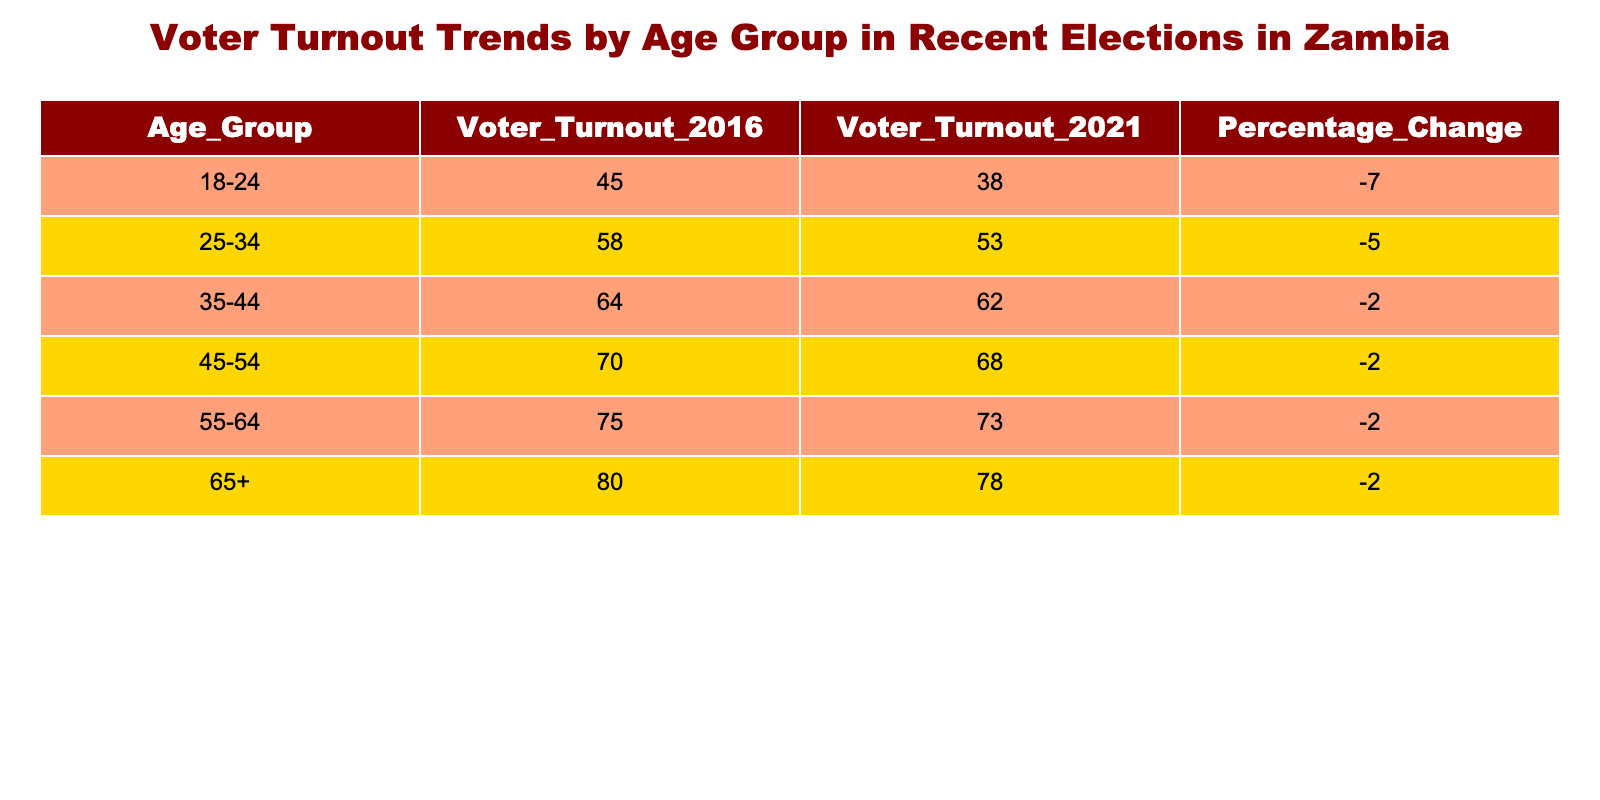What was the voter turnout for the age group 25-34 in the 2021 elections? The table shows that the voter turnout for the age group 25-34 in the 2021 elections is 53.
Answer: 53 What is the percentage change in voter turnout for those aged 18-24 from the 2016 to 2021 elections? The table indicates a percentage change of -7 from 45 to 38.
Answer: -7 Which age group had the highest voter turnout in 2016? According to the table, the age group 65+ had the highest voter turnout at 80 in 2016.
Answer: 65+ What is the average voter turnout across all age groups in the 2021 elections? To find the average, we sum the voter turnout values for 2021 (38 + 53 + 62 + 68 + 73 + 78 = 372) and divide by the number of age groups (6), resulting in an average of 62.
Answer: 62 Is it true that the voter turnout for the age group 35-44 decreased from 2016 to 2021? Yes, the table shows a decrease from 64 in 2016 to 62 in 2021 for the age group 35-44.
Answer: Yes What age group experienced the least decline in voter turnout from 2016 to 2021? The least decline is seen in the age group 35-44, with a decrease of -2, as all other age groups experienced a decline of -2 or worse.
Answer: 35-44 What can you conclude about the trends in voter turnout for the youngest age group compared to the oldest? The table indicates that the voter turnout for the youngest age group (18-24) decreased by 7, while the oldest age group (65+) only decreased by 2, showcasing that younger voters are less engaged.
Answer: Younger voters are less engaged What is the total voter turnout for the age group 55-64 in both years combined? The total for the age group 55-64 is 75 (2016) + 73 (2021) = 148.
Answer: 148 Which age group had a voter turnout of 70 in the 2016 elections? The age group 45-54 had a voter turnout of 70 in the 2016 elections, according to the table.
Answer: 45-54 